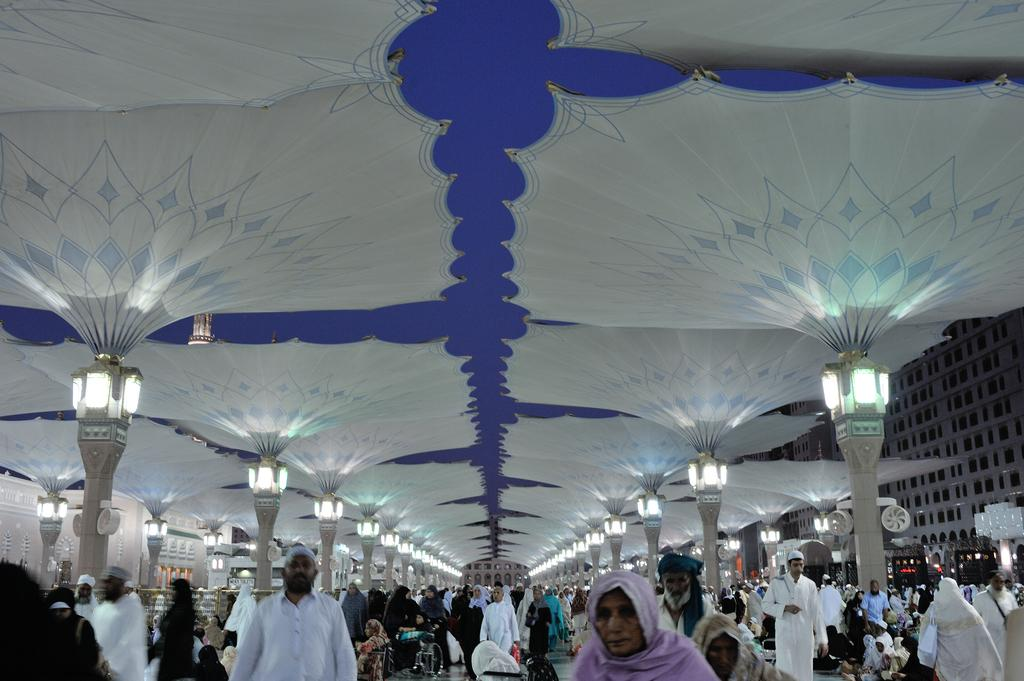Where are the people located in the image? The people are under the tents in the image. What can be seen illuminating the area in the image? There are lights in the image. What is visible in the background of the image? There are vehicles and buildings in the background of the image. What type of straw is being used to sound the alarm in the image? There is no straw or alarm present in the image. What is the cannon used for in the image? There is no cannon present in the image. 